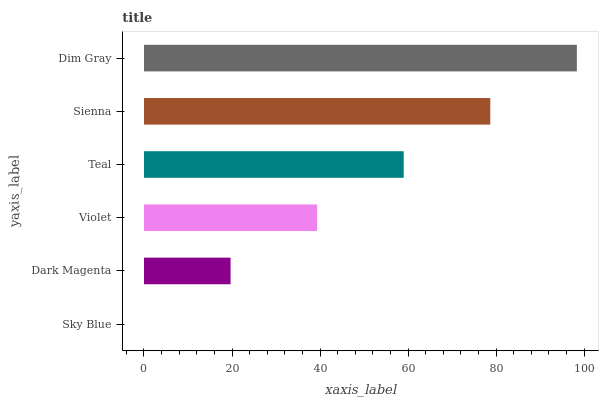Is Sky Blue the minimum?
Answer yes or no. Yes. Is Dim Gray the maximum?
Answer yes or no. Yes. Is Dark Magenta the minimum?
Answer yes or no. No. Is Dark Magenta the maximum?
Answer yes or no. No. Is Dark Magenta greater than Sky Blue?
Answer yes or no. Yes. Is Sky Blue less than Dark Magenta?
Answer yes or no. Yes. Is Sky Blue greater than Dark Magenta?
Answer yes or no. No. Is Dark Magenta less than Sky Blue?
Answer yes or no. No. Is Teal the high median?
Answer yes or no. Yes. Is Violet the low median?
Answer yes or no. Yes. Is Dim Gray the high median?
Answer yes or no. No. Is Sienna the low median?
Answer yes or no. No. 